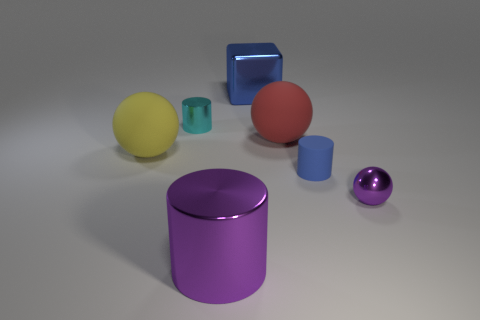How many objects are in the image and can you describe their shapes? There are six objects in the image: two spheres, one cylinder, one cube, one tall cup-like cylinder, and one short, capped cylinder. They display a variety of geometric shapes and are positioned casually around the space. 